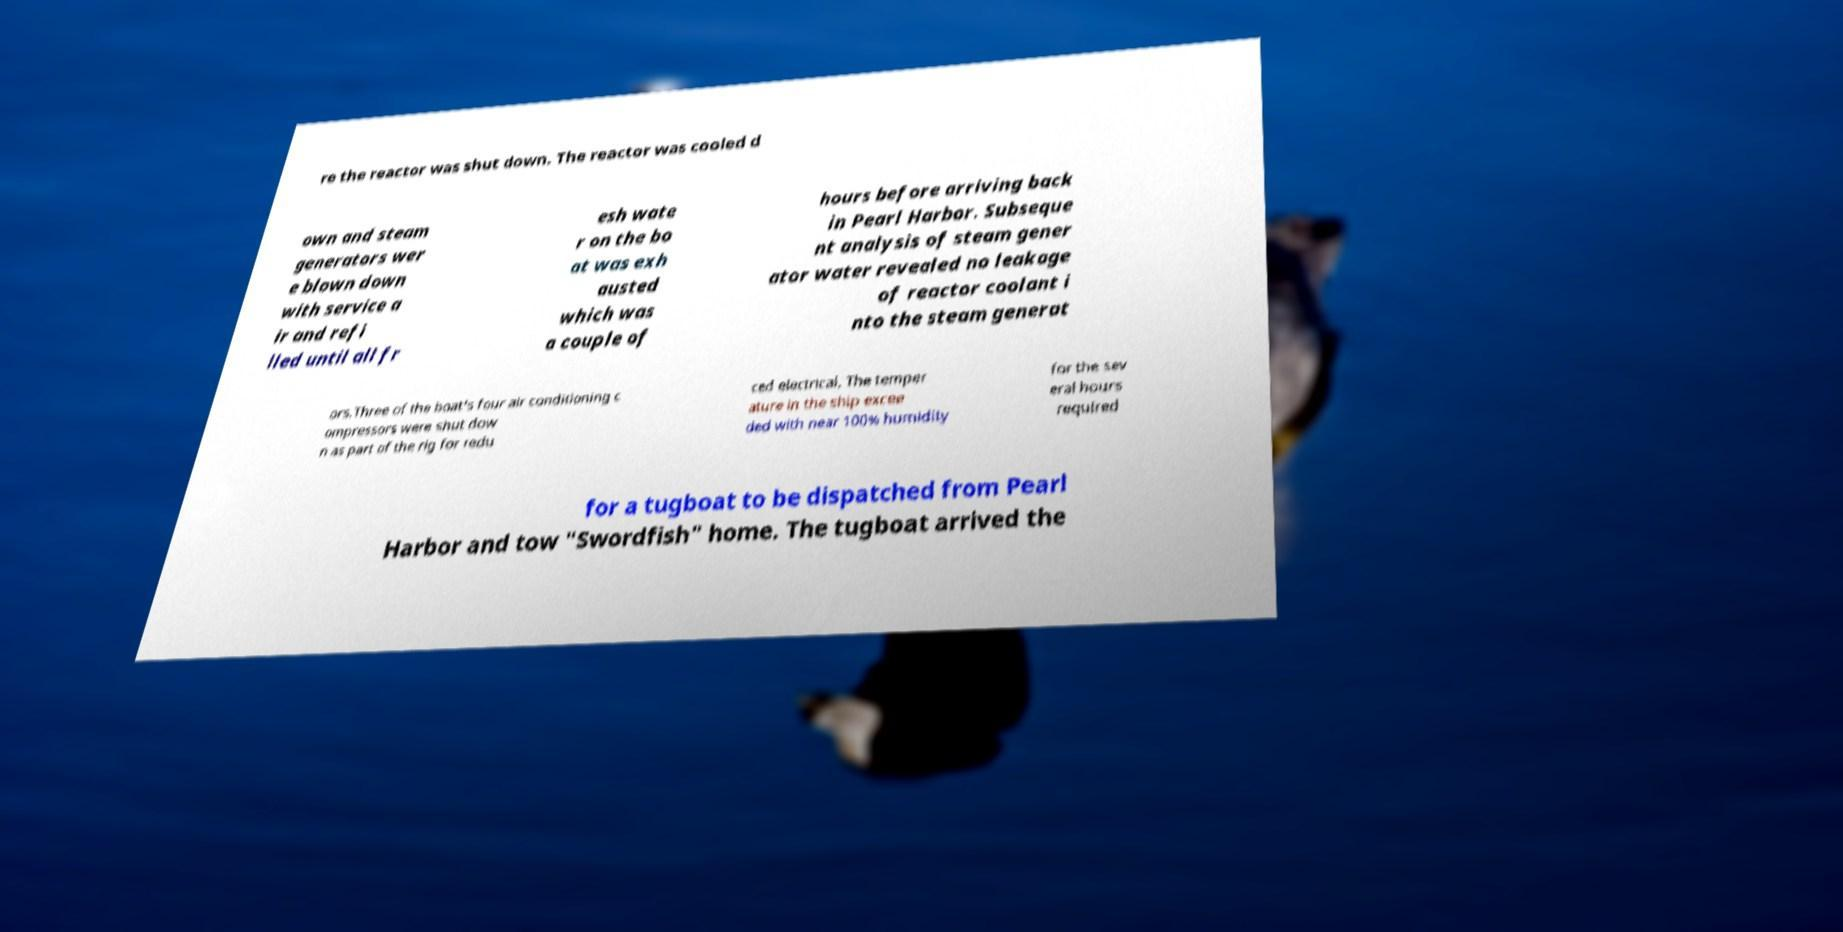I need the written content from this picture converted into text. Can you do that? re the reactor was shut down. The reactor was cooled d own and steam generators wer e blown down with service a ir and refi lled until all fr esh wate r on the bo at was exh austed which was a couple of hours before arriving back in Pearl Harbor. Subseque nt analysis of steam gener ator water revealed no leakage of reactor coolant i nto the steam generat ors.Three of the boat's four air conditioning c ompressors were shut dow n as part of the rig for redu ced electrical. The temper ature in the ship excee ded with near 100% humidity for the sev eral hours required for a tugboat to be dispatched from Pearl Harbor and tow "Swordfish" home. The tugboat arrived the 